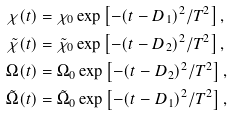<formula> <loc_0><loc_0><loc_500><loc_500>\chi ( t ) & = \chi _ { 0 } \exp \left [ - ( t - D _ { 1 } ) ^ { 2 } / T ^ { 2 } \right ] , \\ \tilde { \chi } ( t ) & = \tilde { \chi } _ { 0 } \exp \left [ - ( t - D _ { 2 } ) ^ { 2 } / T ^ { 2 } \right ] , \\ \Omega ( t ) & = \Omega _ { 0 } \exp \left [ - ( t - D _ { 2 } ) ^ { 2 } / T ^ { 2 } \right ] , \\ \tilde { \Omega } ( t ) & = \tilde { \Omega } _ { 0 } \exp \left [ - ( t - D _ { 1 } ) ^ { 2 } / T ^ { 2 } \right ] ,</formula> 